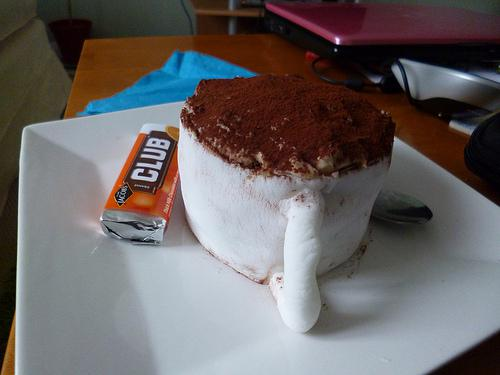Question: what color is the laptop?
Choices:
A. Black.
B. Silver.
C. White.
D. Pink.
Answer with the letter. Answer: D Question: what color is the table?
Choices:
A. Silver.
B. Blue.
C. Black.
D. Brown.
Answer with the letter. Answer: D Question: where is the spoon?
Choices:
A. Next to the bowl.
B. In the bowl.
C. On plate.
D. In a cup.
Answer with the letter. Answer: C Question: what does the candy bar say?
Choices:
A. Reese's.
B. Snickers.
C. Butterfinger.
D. Club.
Answer with the letter. Answer: D 